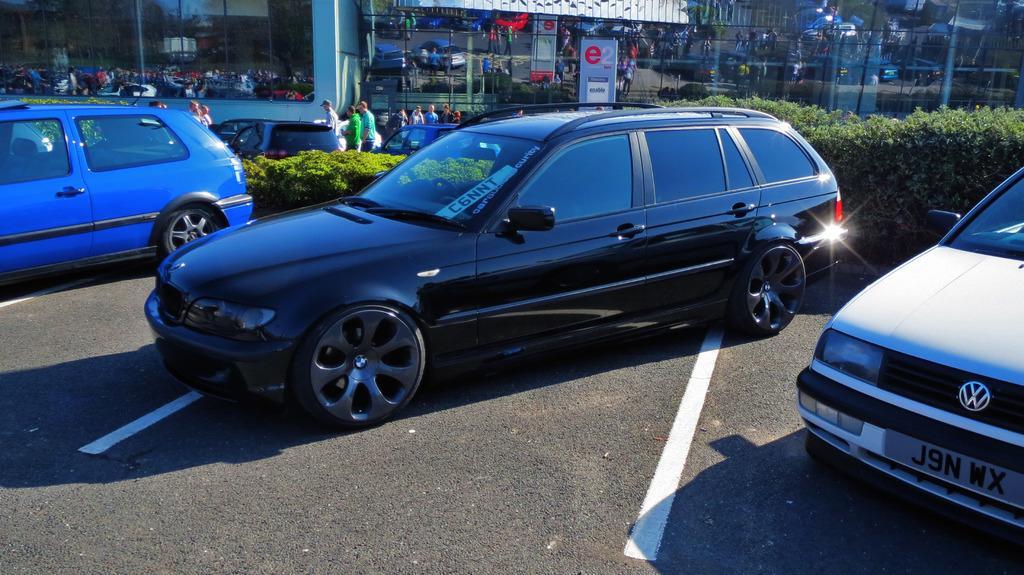Describe this image in one or two sentences. This is the picture of a road. In this image there are vehicles on the road and there are group of people on the road and there are plants. At the back there is a building and there is a reflection of vehicles, group of people and plants and hoarding on the building. There is a hoarding behind the plants. At the bottom there is a road. 